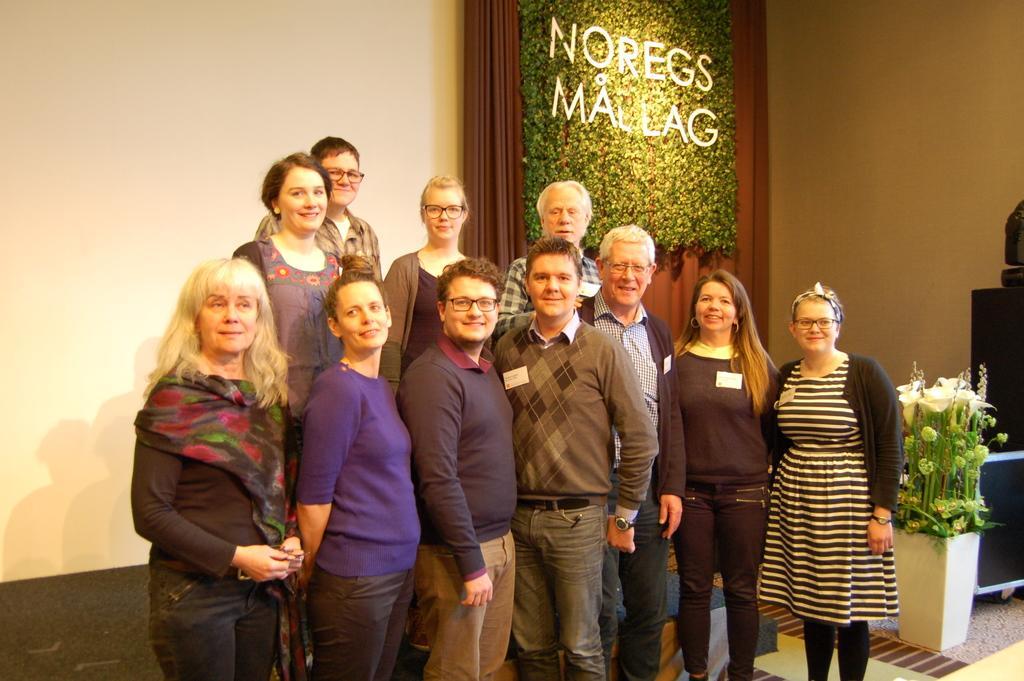Can you describe this image briefly? In this image we can see six women and five men are standing and smiling. There is a wall in the background and brown color curtain is present. We can see potted plant and black color thing on the right side of the image. On curtain, leaves and some text is there. 